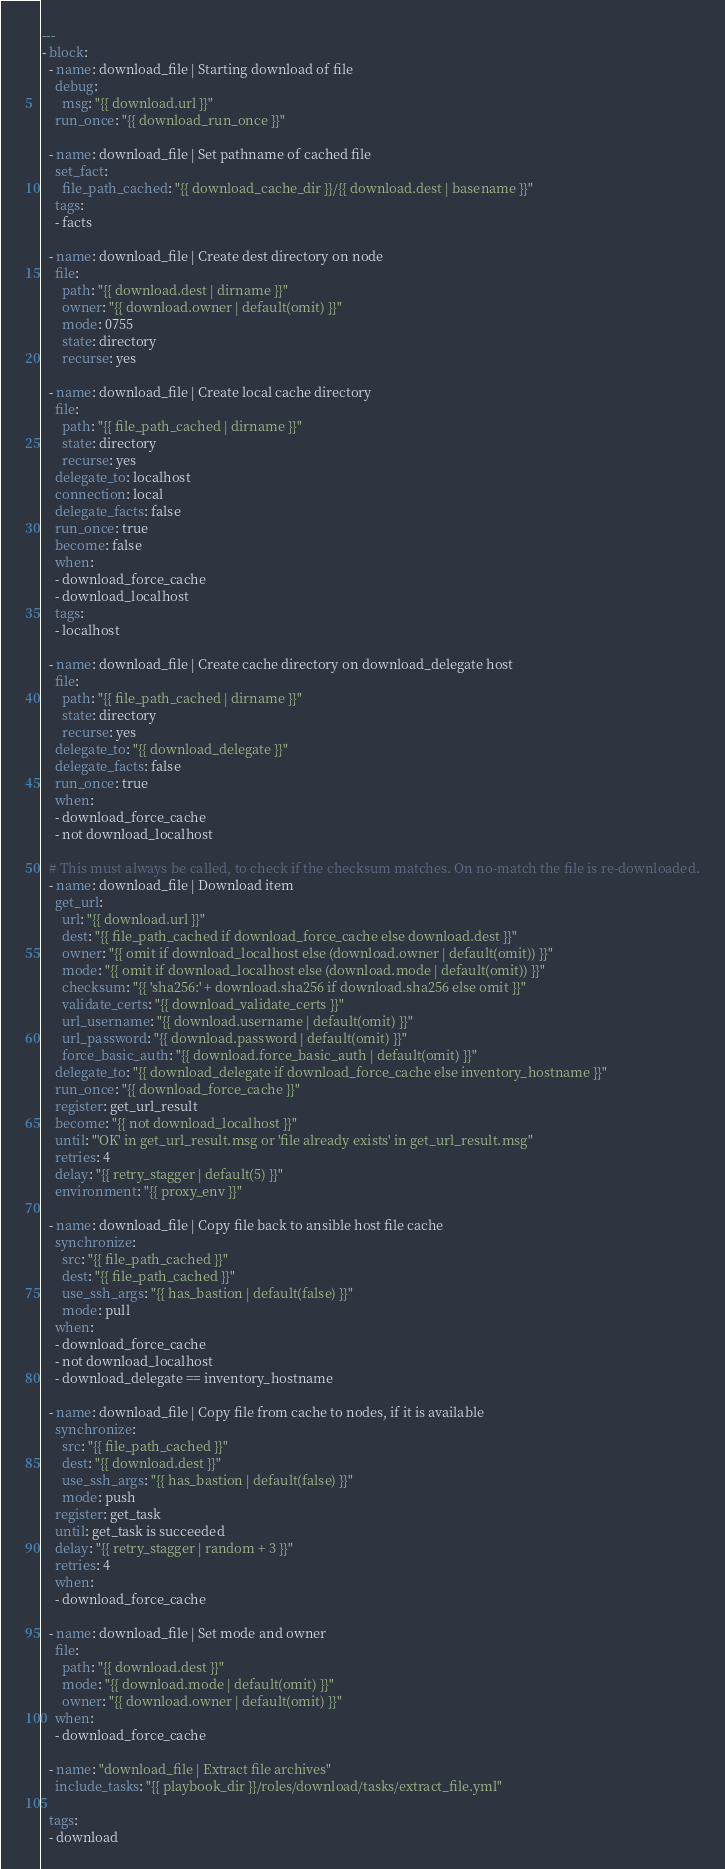Convert code to text. <code><loc_0><loc_0><loc_500><loc_500><_YAML_>---
- block:
  - name: download_file | Starting download of file
    debug:
      msg: "{{ download.url }}"
    run_once: "{{ download_run_once }}"

  - name: download_file | Set pathname of cached file
    set_fact:
      file_path_cached: "{{ download_cache_dir }}/{{ download.dest | basename }}"
    tags:
    - facts

  - name: download_file | Create dest directory on node
    file:
      path: "{{ download.dest | dirname }}"
      owner: "{{ download.owner | default(omit) }}"
      mode: 0755
      state: directory
      recurse: yes

  - name: download_file | Create local cache directory
    file:
      path: "{{ file_path_cached | dirname }}"
      state: directory
      recurse: yes
    delegate_to: localhost
    connection: local
    delegate_facts: false
    run_once: true
    become: false
    when:
    - download_force_cache
    - download_localhost
    tags:
    - localhost

  - name: download_file | Create cache directory on download_delegate host
    file:
      path: "{{ file_path_cached | dirname }}"
      state: directory
      recurse: yes
    delegate_to: "{{ download_delegate }}"
    delegate_facts: false
    run_once: true
    when:
    - download_force_cache
    - not download_localhost

  # This must always be called, to check if the checksum matches. On no-match the file is re-downloaded.
  - name: download_file | Download item
    get_url:
      url: "{{ download.url }}"
      dest: "{{ file_path_cached if download_force_cache else download.dest }}"
      owner: "{{ omit if download_localhost else (download.owner | default(omit)) }}"
      mode: "{{ omit if download_localhost else (download.mode | default(omit)) }}"
      checksum: "{{ 'sha256:' + download.sha256 if download.sha256 else omit }}"
      validate_certs: "{{ download_validate_certs }}"
      url_username: "{{ download.username | default(omit) }}"
      url_password: "{{ download.password | default(omit) }}"
      force_basic_auth: "{{ download.force_basic_auth | default(omit) }}"
    delegate_to: "{{ download_delegate if download_force_cache else inventory_hostname }}"
    run_once: "{{ download_force_cache }}"
    register: get_url_result
    become: "{{ not download_localhost }}"
    until: "'OK' in get_url_result.msg or 'file already exists' in get_url_result.msg"
    retries: 4
    delay: "{{ retry_stagger | default(5) }}"
    environment: "{{ proxy_env }}"

  - name: download_file | Copy file back to ansible host file cache
    synchronize:
      src: "{{ file_path_cached }}"
      dest: "{{ file_path_cached }}"
      use_ssh_args: "{{ has_bastion | default(false) }}"
      mode: pull
    when:
    - download_force_cache
    - not download_localhost
    - download_delegate == inventory_hostname

  - name: download_file | Copy file from cache to nodes, if it is available
    synchronize:
      src: "{{ file_path_cached }}"
      dest: "{{ download.dest }}"
      use_ssh_args: "{{ has_bastion | default(false) }}"
      mode: push
    register: get_task
    until: get_task is succeeded
    delay: "{{ retry_stagger | random + 3 }}"
    retries: 4
    when:
    - download_force_cache

  - name: download_file | Set mode and owner
    file:
      path: "{{ download.dest }}"
      mode: "{{ download.mode | default(omit) }}"
      owner: "{{ download.owner | default(omit) }}"
    when:
    - download_force_cache

  - name: "download_file | Extract file archives"
    include_tasks: "{{ playbook_dir }}/roles/download/tasks/extract_file.yml"

  tags:
  - download
</code> 